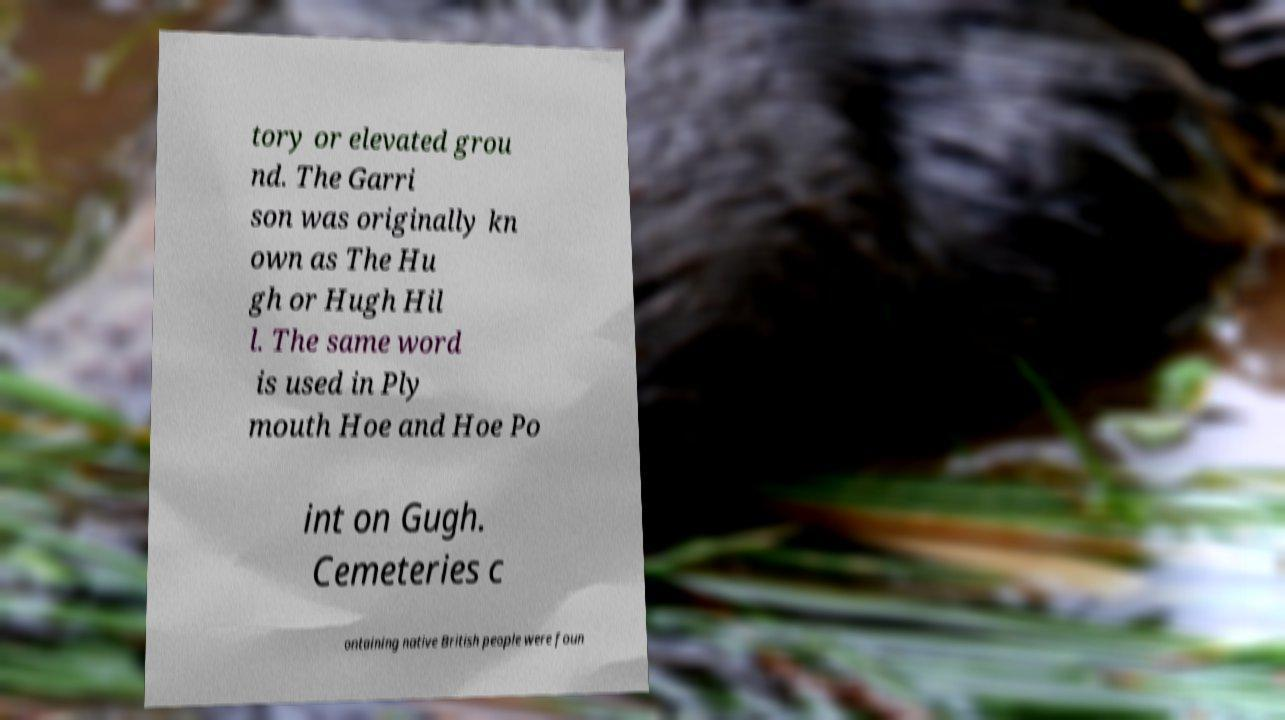Please identify and transcribe the text found in this image. tory or elevated grou nd. The Garri son was originally kn own as The Hu gh or Hugh Hil l. The same word is used in Ply mouth Hoe and Hoe Po int on Gugh. Cemeteries c ontaining native British people were foun 